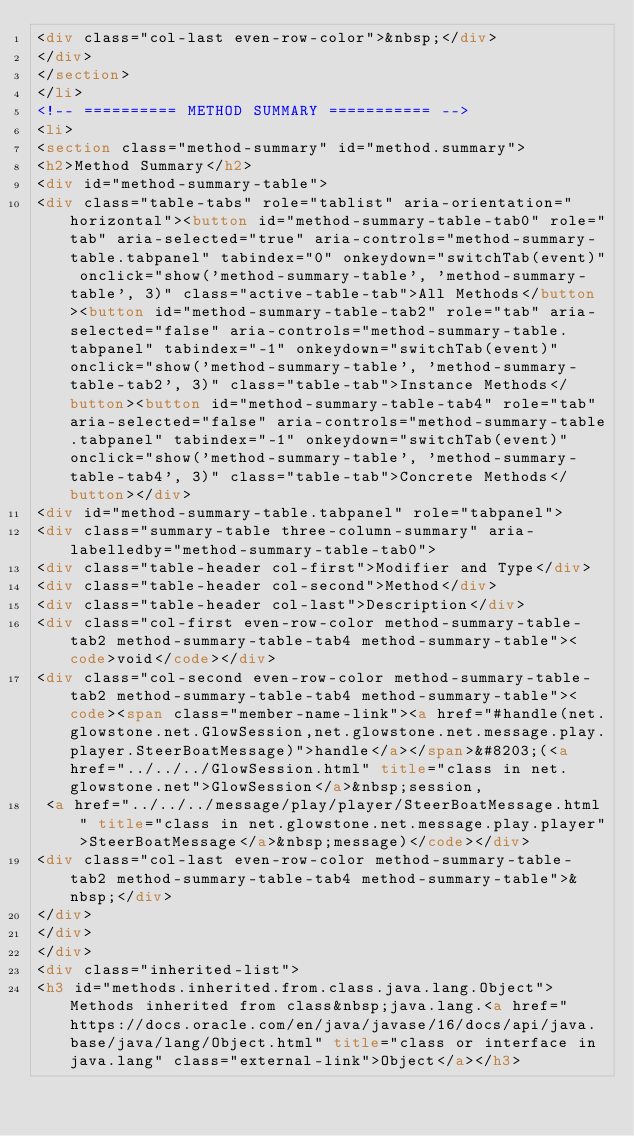<code> <loc_0><loc_0><loc_500><loc_500><_HTML_><div class="col-last even-row-color">&nbsp;</div>
</div>
</section>
</li>
<!-- ========== METHOD SUMMARY =========== -->
<li>
<section class="method-summary" id="method.summary">
<h2>Method Summary</h2>
<div id="method-summary-table">
<div class="table-tabs" role="tablist" aria-orientation="horizontal"><button id="method-summary-table-tab0" role="tab" aria-selected="true" aria-controls="method-summary-table.tabpanel" tabindex="0" onkeydown="switchTab(event)" onclick="show('method-summary-table', 'method-summary-table', 3)" class="active-table-tab">All Methods</button><button id="method-summary-table-tab2" role="tab" aria-selected="false" aria-controls="method-summary-table.tabpanel" tabindex="-1" onkeydown="switchTab(event)" onclick="show('method-summary-table', 'method-summary-table-tab2', 3)" class="table-tab">Instance Methods</button><button id="method-summary-table-tab4" role="tab" aria-selected="false" aria-controls="method-summary-table.tabpanel" tabindex="-1" onkeydown="switchTab(event)" onclick="show('method-summary-table', 'method-summary-table-tab4', 3)" class="table-tab">Concrete Methods</button></div>
<div id="method-summary-table.tabpanel" role="tabpanel">
<div class="summary-table three-column-summary" aria-labelledby="method-summary-table-tab0">
<div class="table-header col-first">Modifier and Type</div>
<div class="table-header col-second">Method</div>
<div class="table-header col-last">Description</div>
<div class="col-first even-row-color method-summary-table-tab2 method-summary-table-tab4 method-summary-table"><code>void</code></div>
<div class="col-second even-row-color method-summary-table-tab2 method-summary-table-tab4 method-summary-table"><code><span class="member-name-link"><a href="#handle(net.glowstone.net.GlowSession,net.glowstone.net.message.play.player.SteerBoatMessage)">handle</a></span>&#8203;(<a href="../../../GlowSession.html" title="class in net.glowstone.net">GlowSession</a>&nbsp;session,
 <a href="../../../message/play/player/SteerBoatMessage.html" title="class in net.glowstone.net.message.play.player">SteerBoatMessage</a>&nbsp;message)</code></div>
<div class="col-last even-row-color method-summary-table-tab2 method-summary-table-tab4 method-summary-table">&nbsp;</div>
</div>
</div>
</div>
<div class="inherited-list">
<h3 id="methods.inherited.from.class.java.lang.Object">Methods inherited from class&nbsp;java.lang.<a href="https://docs.oracle.com/en/java/javase/16/docs/api/java.base/java/lang/Object.html" title="class or interface in java.lang" class="external-link">Object</a></h3></code> 